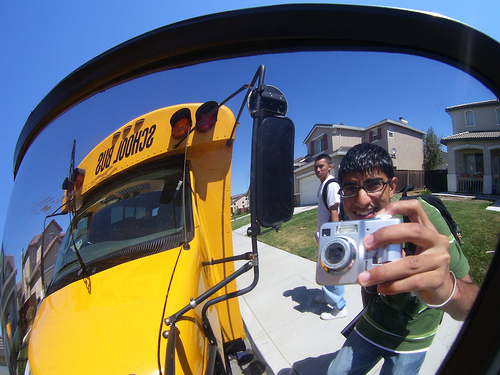Please provide the bounding box coordinate of the region this sentence describes: the pants of a student. The bounding box for the region described by 'the pants of a student' is [0.66, 0.74, 0.83, 0.87]. 